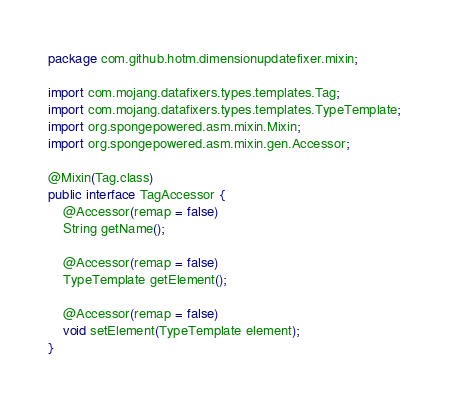<code> <loc_0><loc_0><loc_500><loc_500><_Java_>package com.github.hotm.dimensionupdatefixer.mixin;

import com.mojang.datafixers.types.templates.Tag;
import com.mojang.datafixers.types.templates.TypeTemplate;
import org.spongepowered.asm.mixin.Mixin;
import org.spongepowered.asm.mixin.gen.Accessor;

@Mixin(Tag.class)
public interface TagAccessor {
    @Accessor(remap = false)
    String getName();

    @Accessor(remap = false)
    TypeTemplate getElement();

    @Accessor(remap = false)
    void setElement(TypeTemplate element);
}
</code> 